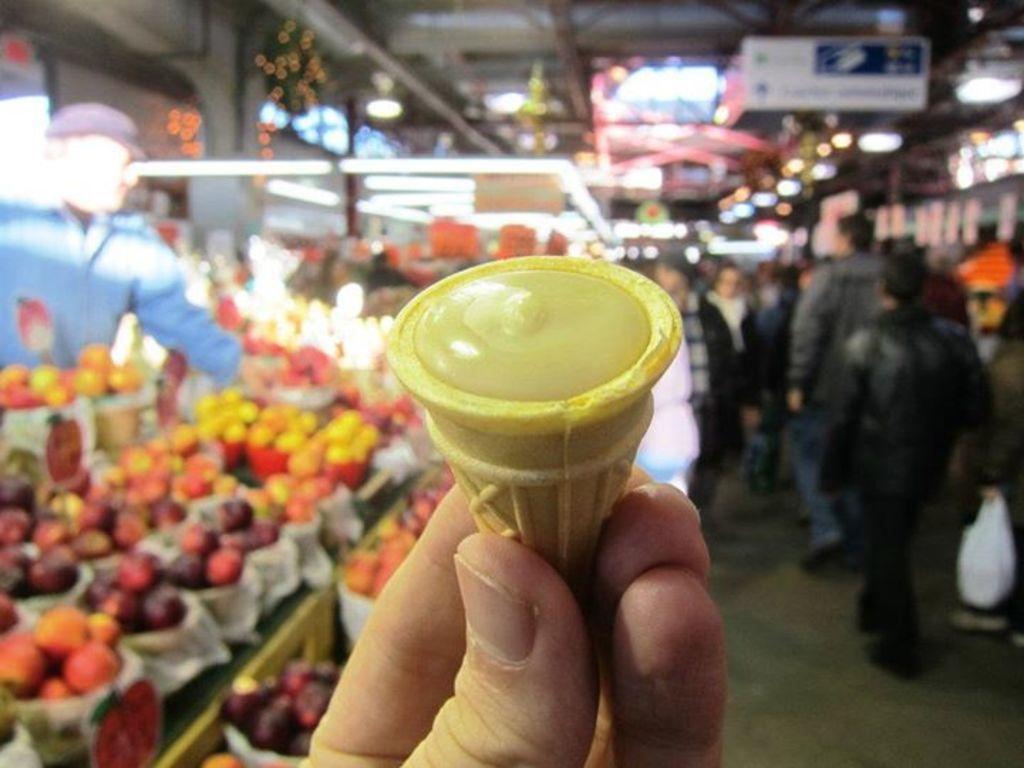How would you summarize this image in a sentence or two? In this picture we can see a person is holding a food item and behind the person hand there are fruits and some people are walking on the floor, boards and some blurred things. 